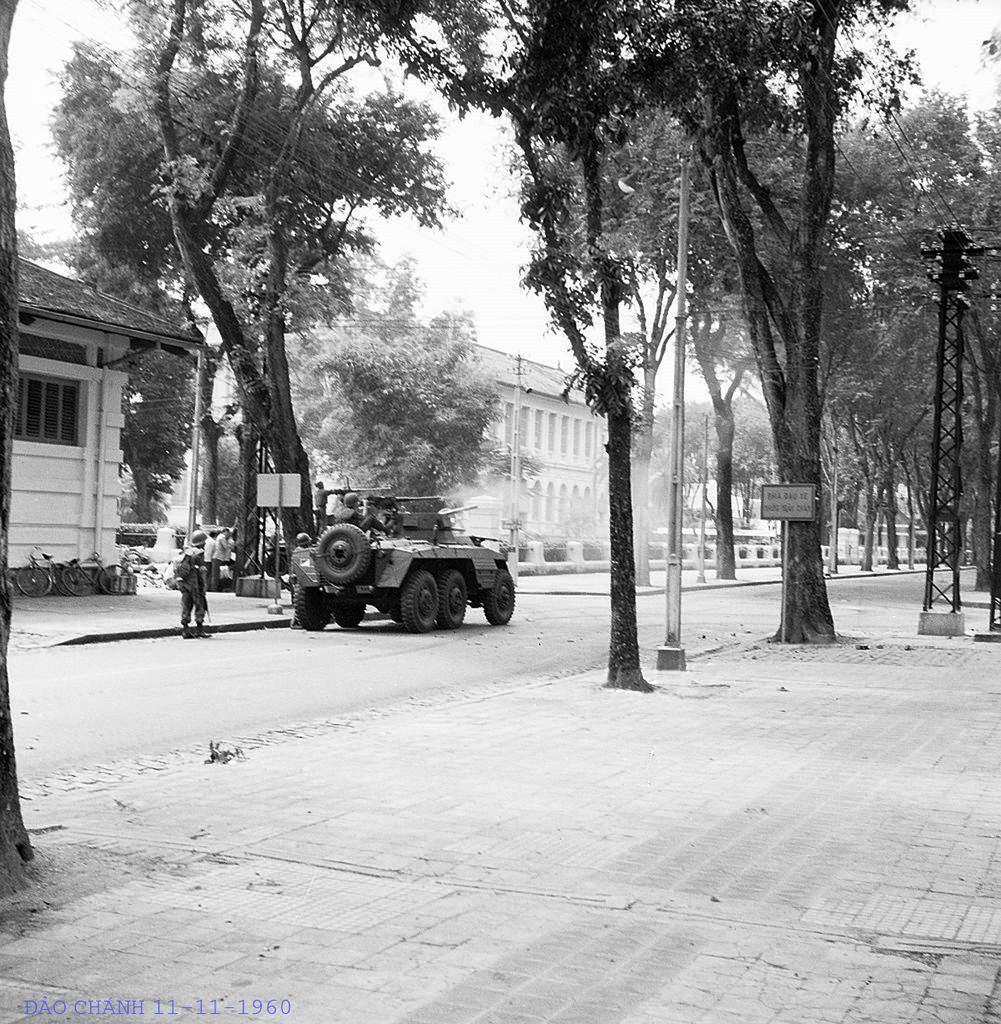Describe this image in one or two sentences. In this image I can see number of trees, few poles, a board, a vehicle, few buildings, few people and few wires. I can also see few people are sitting in this vehicle and here on this board I can see something is written. I can also see this image is black and white in color. 